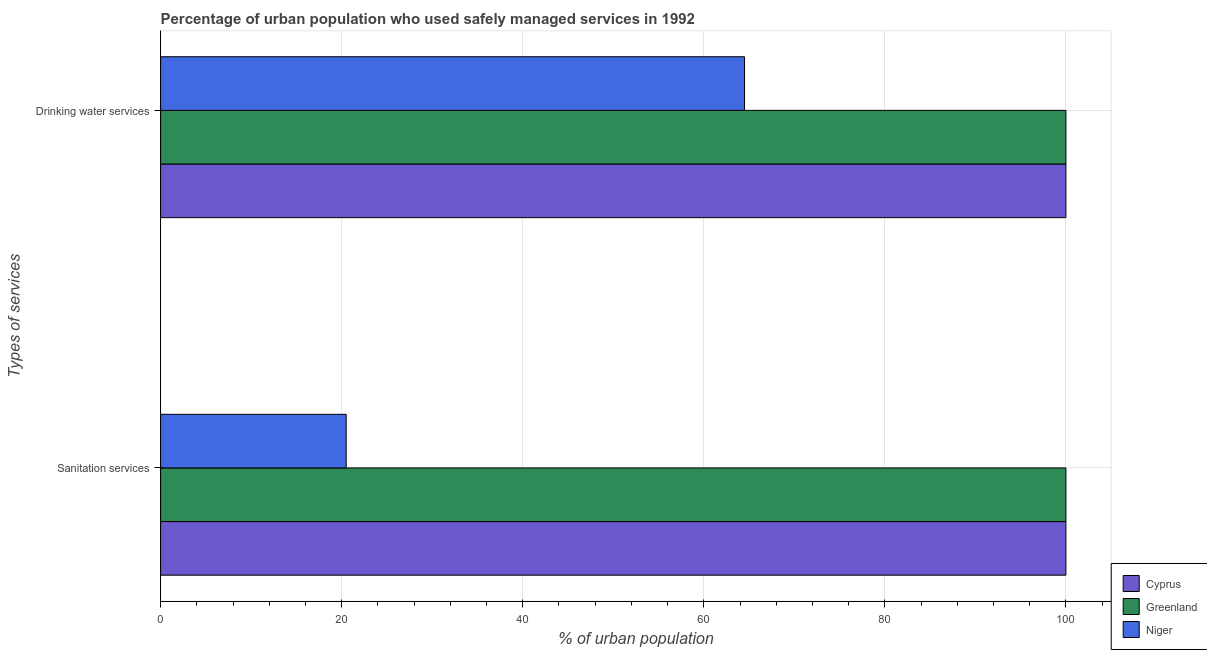Are the number of bars per tick equal to the number of legend labels?
Your answer should be compact. Yes. How many bars are there on the 1st tick from the top?
Offer a very short reply. 3. How many bars are there on the 2nd tick from the bottom?
Offer a very short reply. 3. What is the label of the 1st group of bars from the top?
Ensure brevity in your answer.  Drinking water services. Across all countries, what is the maximum percentage of urban population who used sanitation services?
Give a very brief answer. 100. Across all countries, what is the minimum percentage of urban population who used sanitation services?
Give a very brief answer. 20.5. In which country was the percentage of urban population who used drinking water services maximum?
Your response must be concise. Cyprus. In which country was the percentage of urban population who used drinking water services minimum?
Your answer should be compact. Niger. What is the total percentage of urban population who used drinking water services in the graph?
Offer a terse response. 264.5. What is the difference between the percentage of urban population who used drinking water services in Greenland and that in Niger?
Offer a very short reply. 35.5. What is the difference between the percentage of urban population who used drinking water services in Niger and the percentage of urban population who used sanitation services in Greenland?
Your response must be concise. -35.5. What is the average percentage of urban population who used drinking water services per country?
Give a very brief answer. 88.17. What is the difference between the percentage of urban population who used drinking water services and percentage of urban population who used sanitation services in Niger?
Provide a succinct answer. 44. What is the ratio of the percentage of urban population who used drinking water services in Greenland to that in Cyprus?
Provide a short and direct response. 1. Is the percentage of urban population who used sanitation services in Cyprus less than that in Niger?
Your answer should be very brief. No. In how many countries, is the percentage of urban population who used sanitation services greater than the average percentage of urban population who used sanitation services taken over all countries?
Provide a succinct answer. 2. What does the 3rd bar from the top in Drinking water services represents?
Ensure brevity in your answer.  Cyprus. What does the 1st bar from the bottom in Drinking water services represents?
Make the answer very short. Cyprus. How many bars are there?
Ensure brevity in your answer.  6. Are all the bars in the graph horizontal?
Ensure brevity in your answer.  Yes. How many countries are there in the graph?
Ensure brevity in your answer.  3. Does the graph contain grids?
Provide a short and direct response. Yes. Where does the legend appear in the graph?
Provide a succinct answer. Bottom right. How many legend labels are there?
Offer a terse response. 3. What is the title of the graph?
Give a very brief answer. Percentage of urban population who used safely managed services in 1992. What is the label or title of the X-axis?
Provide a succinct answer. % of urban population. What is the label or title of the Y-axis?
Your response must be concise. Types of services. What is the % of urban population in Greenland in Sanitation services?
Ensure brevity in your answer.  100. What is the % of urban population of Greenland in Drinking water services?
Make the answer very short. 100. What is the % of urban population in Niger in Drinking water services?
Offer a terse response. 64.5. Across all Types of services, what is the maximum % of urban population of Greenland?
Ensure brevity in your answer.  100. Across all Types of services, what is the maximum % of urban population of Niger?
Make the answer very short. 64.5. Across all Types of services, what is the minimum % of urban population in Cyprus?
Give a very brief answer. 100. What is the total % of urban population in Cyprus in the graph?
Provide a succinct answer. 200. What is the total % of urban population in Greenland in the graph?
Ensure brevity in your answer.  200. What is the difference between the % of urban population in Greenland in Sanitation services and that in Drinking water services?
Your answer should be compact. 0. What is the difference between the % of urban population in Niger in Sanitation services and that in Drinking water services?
Your answer should be compact. -44. What is the difference between the % of urban population of Cyprus in Sanitation services and the % of urban population of Niger in Drinking water services?
Make the answer very short. 35.5. What is the difference between the % of urban population in Greenland in Sanitation services and the % of urban population in Niger in Drinking water services?
Your answer should be very brief. 35.5. What is the average % of urban population of Cyprus per Types of services?
Offer a very short reply. 100. What is the average % of urban population of Niger per Types of services?
Ensure brevity in your answer.  42.5. What is the difference between the % of urban population of Cyprus and % of urban population of Niger in Sanitation services?
Provide a succinct answer. 79.5. What is the difference between the % of urban population in Greenland and % of urban population in Niger in Sanitation services?
Keep it short and to the point. 79.5. What is the difference between the % of urban population in Cyprus and % of urban population in Greenland in Drinking water services?
Give a very brief answer. 0. What is the difference between the % of urban population in Cyprus and % of urban population in Niger in Drinking water services?
Your answer should be very brief. 35.5. What is the difference between the % of urban population of Greenland and % of urban population of Niger in Drinking water services?
Make the answer very short. 35.5. What is the ratio of the % of urban population of Greenland in Sanitation services to that in Drinking water services?
Ensure brevity in your answer.  1. What is the ratio of the % of urban population of Niger in Sanitation services to that in Drinking water services?
Offer a terse response. 0.32. What is the difference between the highest and the lowest % of urban population in Cyprus?
Ensure brevity in your answer.  0. What is the difference between the highest and the lowest % of urban population in Niger?
Offer a terse response. 44. 